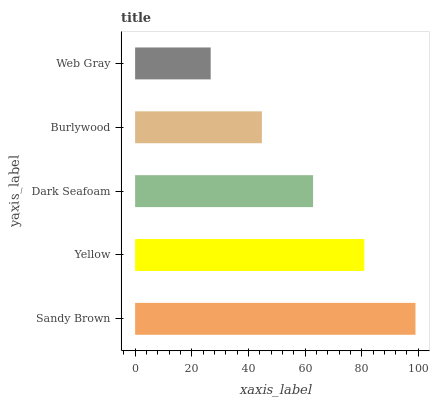Is Web Gray the minimum?
Answer yes or no. Yes. Is Sandy Brown the maximum?
Answer yes or no. Yes. Is Yellow the minimum?
Answer yes or no. No. Is Yellow the maximum?
Answer yes or no. No. Is Sandy Brown greater than Yellow?
Answer yes or no. Yes. Is Yellow less than Sandy Brown?
Answer yes or no. Yes. Is Yellow greater than Sandy Brown?
Answer yes or no. No. Is Sandy Brown less than Yellow?
Answer yes or no. No. Is Dark Seafoam the high median?
Answer yes or no. Yes. Is Dark Seafoam the low median?
Answer yes or no. Yes. Is Web Gray the high median?
Answer yes or no. No. Is Web Gray the low median?
Answer yes or no. No. 